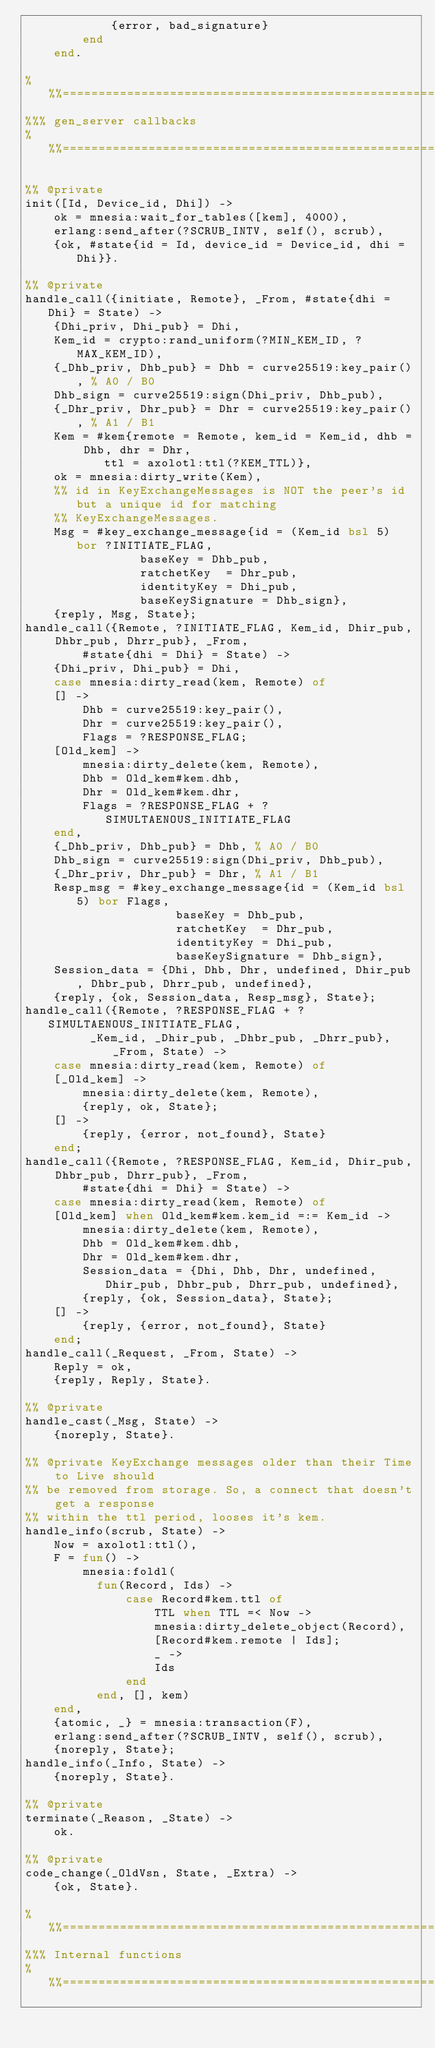<code> <loc_0><loc_0><loc_500><loc_500><_Erlang_>		    {error, bad_signature}
	    end
    end.

%%%===================================================================
%%% gen_server callbacks
%%%===================================================================

%% @private
init([Id, Device_id, Dhi]) ->
    ok = mnesia:wait_for_tables([kem], 4000),
    erlang:send_after(?SCRUB_INTV, self(), scrub),
    {ok, #state{id = Id, device_id = Device_id, dhi = Dhi}}.

%% @private
handle_call({initiate, Remote}, _From, #state{dhi = Dhi} = State) ->
    {Dhi_priv, Dhi_pub} = Dhi,
    Kem_id = crypto:rand_uniform(?MIN_KEM_ID, ?MAX_KEM_ID),
    {_Dhb_priv, Dhb_pub} = Dhb = curve25519:key_pair(), % A0 / B0
    Dhb_sign = curve25519:sign(Dhi_priv, Dhb_pub),
    {_Dhr_priv, Dhr_pub} = Dhr = curve25519:key_pair(), % A1 / B1
    Kem = #kem{remote = Remote, kem_id = Kem_id, dhb = Dhb, dhr = Dhr, 
	       ttl = axolotl:ttl(?KEM_TTL)},	
    ok = mnesia:dirty_write(Kem),
    %% id in KeyExchangeMessages is NOT the peer's id but a unique id for matching
    %% KeyExchangeMessages.
    Msg = #key_exchange_message{id = (Kem_id bsl 5) bor ?INITIATE_FLAG,
				baseKey = Dhb_pub, 
				ratchetKey  = Dhr_pub, 
				identityKey = Dhi_pub, 
				baseKeySignature = Dhb_sign},
    {reply, Msg, State};
handle_call({Remote, ?INITIATE_FLAG, Kem_id, Dhir_pub, Dhbr_pub, Dhrr_pub}, _From, 
	    #state{dhi = Dhi} = State) ->
    {Dhi_priv, Dhi_pub} = Dhi,
    case mnesia:dirty_read(kem, Remote) of
	[] ->
	    Dhb = curve25519:key_pair(),
	    Dhr = curve25519:key_pair(),
	    Flags = ?RESPONSE_FLAG;
	[Old_kem] ->
	    mnesia:dirty_delete(kem, Remote),
	    Dhb = Old_kem#kem.dhb,
	    Dhr = Old_kem#kem.dhr,
	    Flags = ?RESPONSE_FLAG + ?SIMULTAENOUS_INITIATE_FLAG
    end,
    {_Dhb_priv, Dhb_pub} = Dhb, % A0 / B0
    Dhb_sign = curve25519:sign(Dhi_priv, Dhb_pub),
    {_Dhr_priv, Dhr_pub} = Dhr, % A1 / B1
    Resp_msg = #key_exchange_message{id = (Kem_id bsl 5) bor Flags,
				     baseKey = Dhb_pub, 
				     ratchetKey  = Dhr_pub, 
				     identityKey = Dhi_pub, 
				     baseKeySignature = Dhb_sign},
    Session_data = {Dhi, Dhb, Dhr, undefined, Dhir_pub, Dhbr_pub, Dhrr_pub, undefined},
    {reply, {ok, Session_data, Resp_msg}, State};    
handle_call({Remote, ?RESPONSE_FLAG + ?SIMULTAENOUS_INITIATE_FLAG,
	     _Kem_id, _Dhir_pub, _Dhbr_pub, _Dhrr_pub}, _From, State) ->
    case mnesia:dirty_read(kem, Remote) of
	[_Old_kem] ->
	    mnesia:dirty_delete(kem, Remote),
	    {reply, ok, State};
	[] ->
	    {reply, {error, not_found}, State}
    end;
handle_call({Remote, ?RESPONSE_FLAG, Kem_id, Dhir_pub, Dhbr_pub, Dhrr_pub}, _From, 
	    #state{dhi = Dhi} = State) ->
    case mnesia:dirty_read(kem, Remote) of
	[Old_kem] when Old_kem#kem.kem_id =:= Kem_id ->
	    mnesia:dirty_delete(kem, Remote),
	    Dhb = Old_kem#kem.dhb,
	    Dhr = Old_kem#kem.dhr,
	    Session_data = {Dhi, Dhb, Dhr, undefined, Dhir_pub, Dhbr_pub, Dhrr_pub, undefined},
	    {reply, {ok, Session_data}, State};
	[] ->
	    {reply, {error, not_found}, State}
    end;
handle_call(_Request, _From, State) ->
    Reply = ok,
    {reply, Reply, State}.

%% @private
handle_cast(_Msg, State) ->
    {noreply, State}.

%% @private KeyExchange messages older than their Time to Live should
%% be removed from storage. So, a connect that doesn't get a response
%% within the ttl period, looses it's kem.
handle_info(scrub, State) ->
    Now = axolotl:ttl(),
    F = fun() ->
		mnesia:foldl(
		  fun(Record, Ids) ->
			  case Record#kem.ttl of
			      TTL when TTL =< Now ->
				  mnesia:dirty_delete_object(Record),
				  [Record#kem.remote | Ids];
			      _ ->
				  Ids
			  end
		  end, [], kem)
	end,
    {atomic, _} = mnesia:transaction(F),
    erlang:send_after(?SCRUB_INTV, self(), scrub),
    {noreply, State};
handle_info(_Info, State) ->
    {noreply, State}.

%% @private
terminate(_Reason, _State) ->
    ok.

%% @private
code_change(_OldVsn, State, _Extra) ->
    {ok, State}.

%%%===================================================================
%%% Internal functions
%%%===================================================================
</code> 